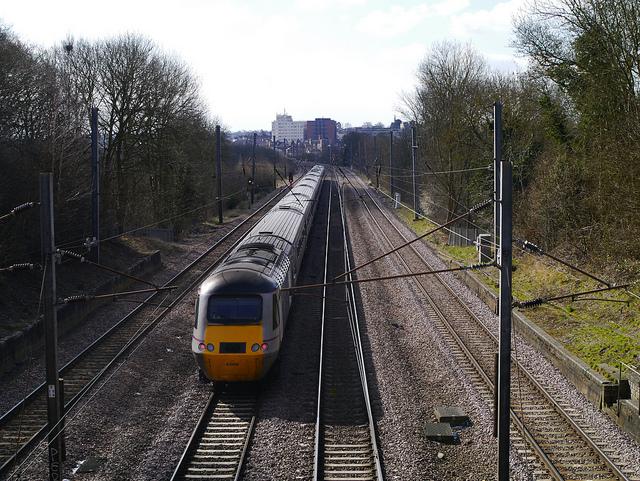What task is this train designed for?
Quick response, please. Transportation. What is coming out of the train?
Answer briefly. Nothing. How many train tracks are there?
Be succinct. 4. How many train cars are there?
Concise answer only. 7. 